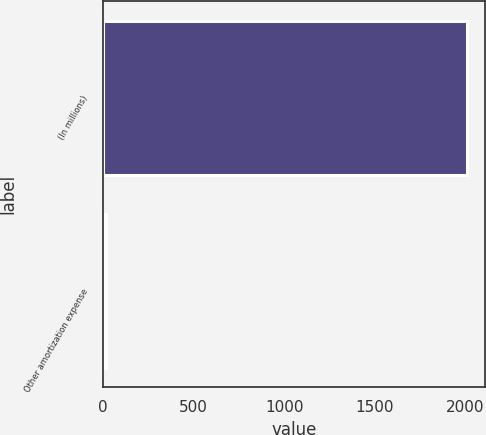<chart> <loc_0><loc_0><loc_500><loc_500><bar_chart><fcel>(In millions)<fcel>Other amortization expense<nl><fcel>2006<fcel>15<nl></chart> 